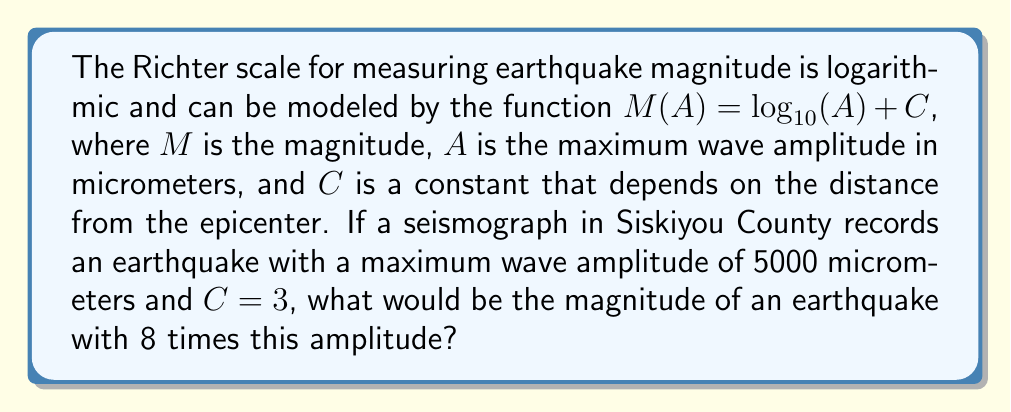Provide a solution to this math problem. Let's approach this step-by-step:

1) First, we need to find the magnitude of the initial earthquake:
   $M_1 = \log_{10}(5000) + 3$
   $M_1 = 3.699 + 3 = 6.699$

2) Now, we need to find the magnitude of an earthquake with 8 times the amplitude:
   $M_2 = \log_{10}(8 \cdot 5000) + 3$

3) We can simplify this using the laws of logarithms:
   $M_2 = \log_{10}(8) + \log_{10}(5000) + 3$

4) We know that $\log_{10}(8) = \log_{10}(2^3) = 3\log_{10}(2) \approx 0.903$

5) So now we have:
   $M_2 = 0.903 + \log_{10}(5000) + 3$
   $M_2 = 0.903 + 3.699 + 3 = 7.602$

6) The difference in magnitude is:
   $7.602 - 6.699 = 0.903$

This difference of approximately 0.9 on the Richter scale represents a significant increase in earthquake intensity, as each whole number increase on the Richter scale represents a tenfold increase in wave amplitude.
Answer: 7.602 